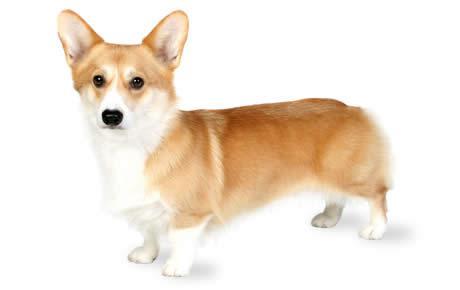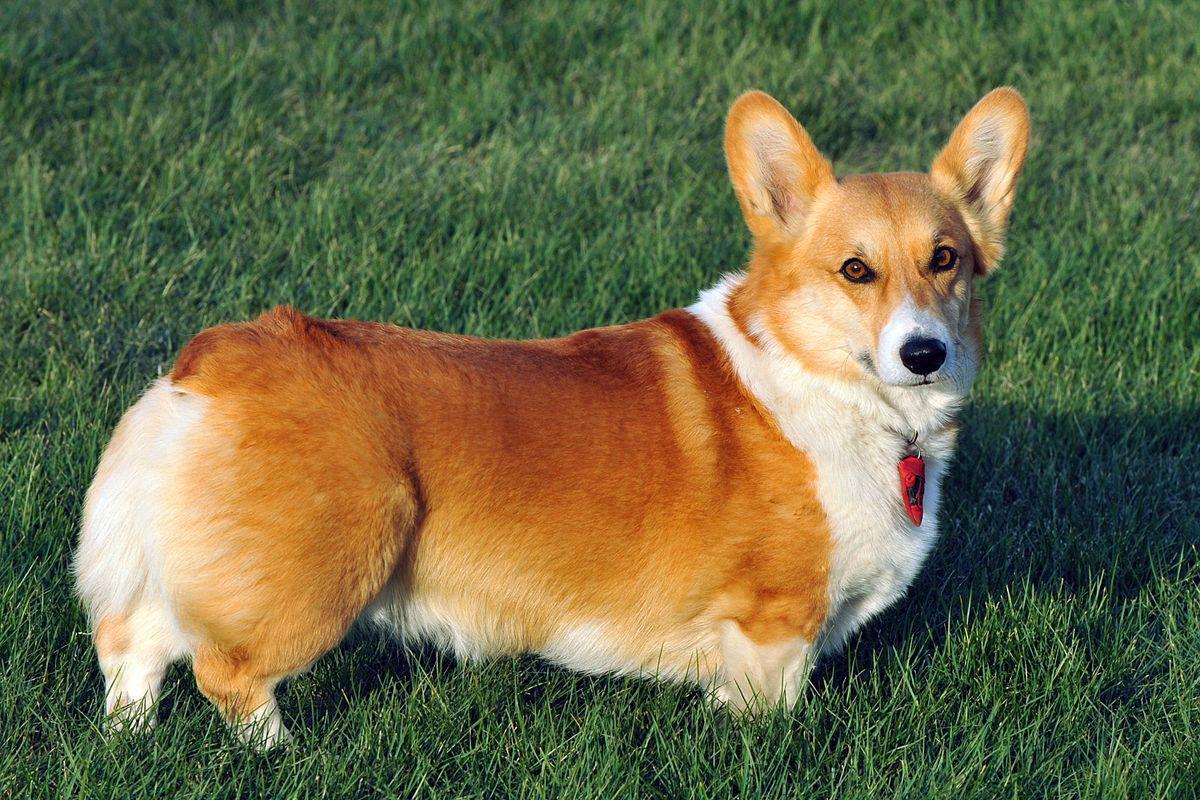The first image is the image on the left, the second image is the image on the right. Analyze the images presented: Is the assertion "Two tan and white dogs have short legs and upright ears." valid? Answer yes or no. Yes. The first image is the image on the left, the second image is the image on the right. Evaluate the accuracy of this statement regarding the images: "The dogs in the images are standing with bodies turned in opposite directions.". Is it true? Answer yes or no. Yes. The first image is the image on the left, the second image is the image on the right. Assess this claim about the two images: "There is a tri-colored dog with a black mask look.". Correct or not? Answer yes or no. No. 